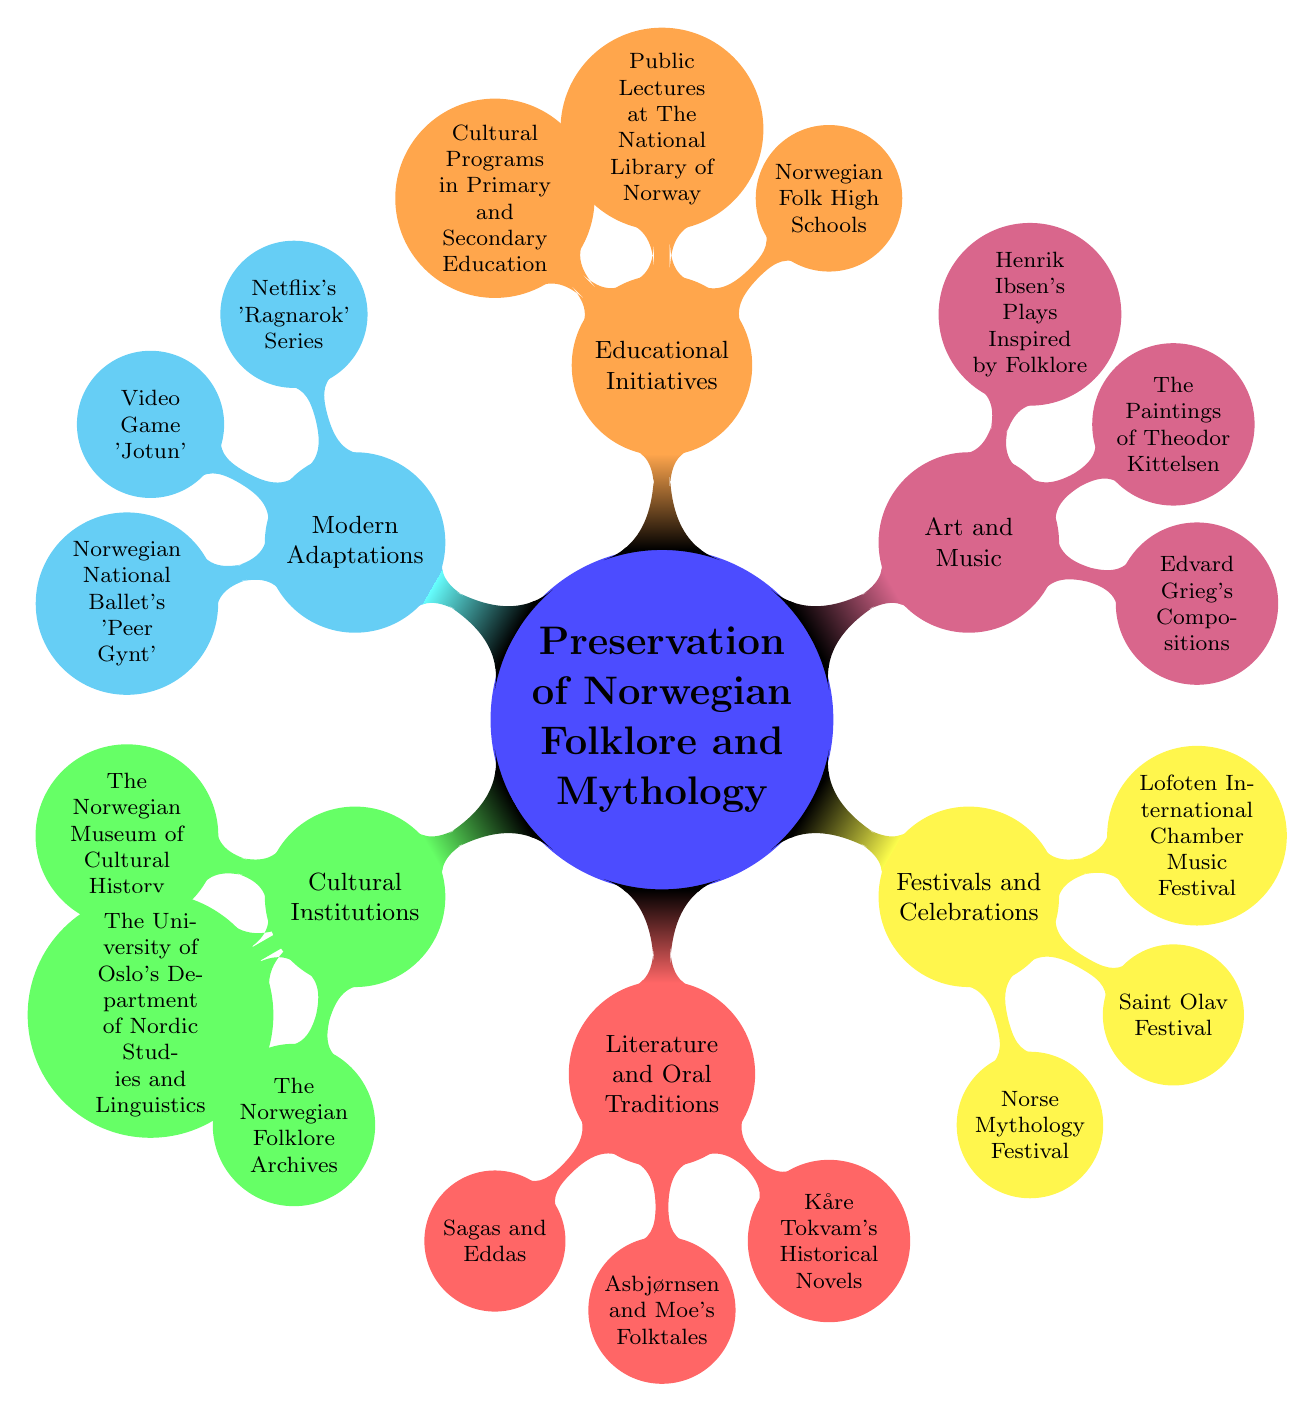What is the main topic of the mind map? The central node of the mind map is labeled "Preservation of Norwegian Folklore and Mythology," indicating that this is the main topic being explored.
Answer: Preservation of Norwegian Folklore and Mythology How many subtopics are there in the diagram? By counting the child nodes branching from the main topic, we find there are six subtopics: Cultural Institutions, Literature and Oral Traditions, Festivals and Celebrations, Art and Music, Educational Initiatives, and Modern Adaptations.
Answer: 6 Which cultural institution is part of the subtopic "Cultural Institutions"? The subtopic "Cultural Institutions" consists of three elements: The Norwegian Museum of Cultural History, The University of Oslo's Department of Nordic Studies and Linguistics, and The Norwegian Folklore Archives. One example given is The Norwegian Museum of Cultural History.
Answer: The Norwegian Museum of Cultural History What are the elements listed under "Modern Adaptations"? The subtopic "Modern Adaptations" features three elements that show how folklore and mythology are interpreted in contemporary contexts: Netflix's 'Ragnarok' Series, Video Game 'Jotun', and Norwegian National Ballet's 'Peer Gynt'.
Answer: Netflix's 'Ragnarok' Series, Video Game 'Jotun', Norwegian National Ballet's 'Peer Gynt' Which festival corresponds to the celebration of Norse mythology? The subtopic "Festivals and Celebrations" lists three events, one of which is the Norse Mythology Festival. Thus, this festival specifically addresses the theme of Norse mythology.
Answer: Norse Mythology Festival What role does the Norwegian Museum of Cultural History play in preserving folklore? The Norwegian Museum of Cultural History is part of the "Cultural Institutions" subtopic, which suggests it plays an essential role in the wider effort to preserve and promote Norwegian folklore and heritage. Therefore, its role is directly linked to preservation.
Answer: Preservation role Which art form is represented by Edvard Grieg? Within the "Art and Music" subtopic, Edvard Grieg is mentioned as a prominent figure, known for his compositions that are inspired by Norwegian culture, thus linking him to the preservation of folklore through musical art.
Answer: Compositions How do Norwegian Folk High Schools contribute to folklore preservation? Listed under "Educational Initiatives," Norwegian Folk High Schools are institutions dedicated to folk education and cultural studies, providing programs that promote the understanding and appreciation of Norwegian folklore, thereby contributing to its preservation.
Answer: Education and preservation 